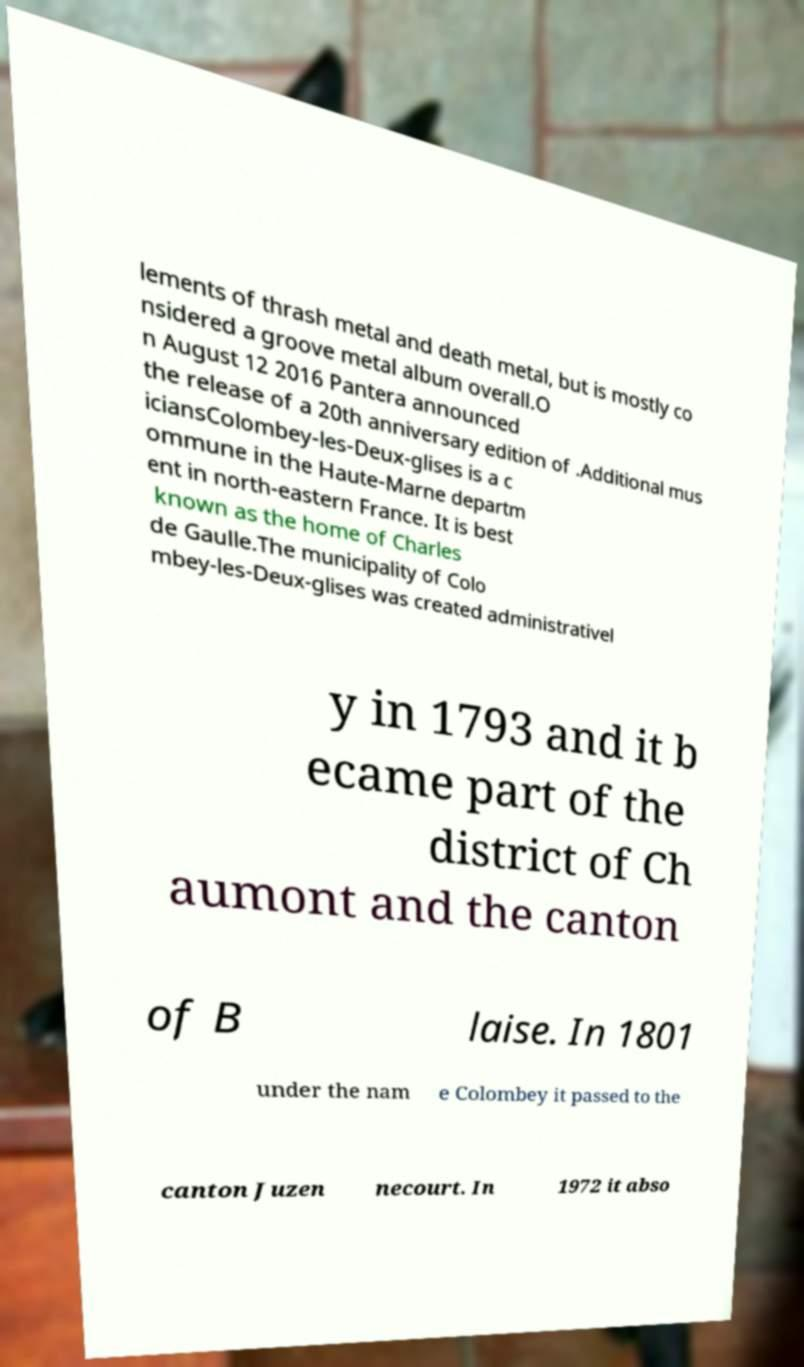What messages or text are displayed in this image? I need them in a readable, typed format. lements of thrash metal and death metal, but is mostly co nsidered a groove metal album overall.O n August 12 2016 Pantera announced the release of a 20th anniversary edition of .Additional mus iciansColombey-les-Deux-glises is a c ommune in the Haute-Marne departm ent in north-eastern France. It is best known as the home of Charles de Gaulle.The municipality of Colo mbey-les-Deux-glises was created administrativel y in 1793 and it b ecame part of the district of Ch aumont and the canton of B laise. In 1801 under the nam e Colombey it passed to the canton Juzen necourt. In 1972 it abso 